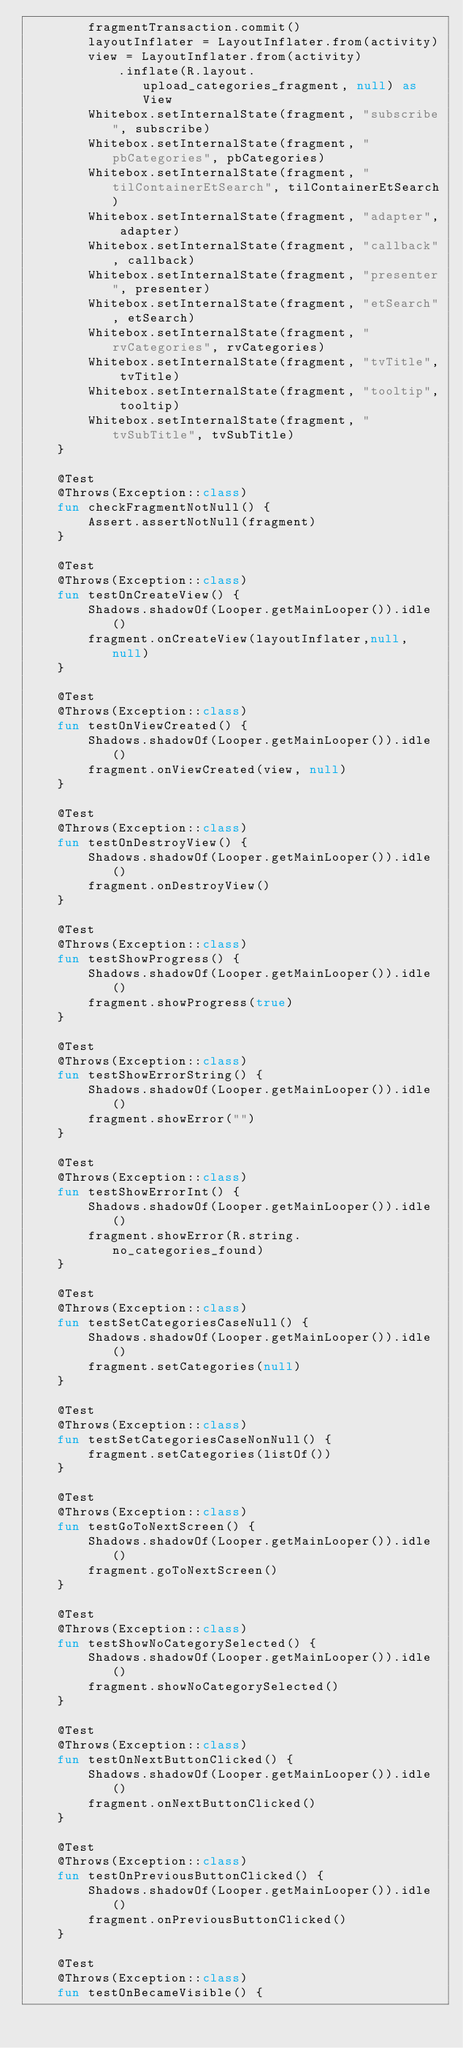Convert code to text. <code><loc_0><loc_0><loc_500><loc_500><_Kotlin_>        fragmentTransaction.commit()
        layoutInflater = LayoutInflater.from(activity)
        view = LayoutInflater.from(activity)
            .inflate(R.layout.upload_categories_fragment, null) as View
        Whitebox.setInternalState(fragment, "subscribe", subscribe)
        Whitebox.setInternalState(fragment, "pbCategories", pbCategories)
        Whitebox.setInternalState(fragment, "tilContainerEtSearch", tilContainerEtSearch)
        Whitebox.setInternalState(fragment, "adapter", adapter)
        Whitebox.setInternalState(fragment, "callback", callback)
        Whitebox.setInternalState(fragment, "presenter", presenter)
        Whitebox.setInternalState(fragment, "etSearch", etSearch)
        Whitebox.setInternalState(fragment, "rvCategories", rvCategories)
        Whitebox.setInternalState(fragment, "tvTitle", tvTitle)
        Whitebox.setInternalState(fragment, "tooltip", tooltip)
        Whitebox.setInternalState(fragment, "tvSubTitle", tvSubTitle)
    }

    @Test
    @Throws(Exception::class)
    fun checkFragmentNotNull() {
        Assert.assertNotNull(fragment)
    }

    @Test
    @Throws(Exception::class)
    fun testOnCreateView() {
        Shadows.shadowOf(Looper.getMainLooper()).idle()
        fragment.onCreateView(layoutInflater,null, null)
    }

    @Test
    @Throws(Exception::class)
    fun testOnViewCreated() {
        Shadows.shadowOf(Looper.getMainLooper()).idle()
        fragment.onViewCreated(view, null)
    }

    @Test
    @Throws(Exception::class)
    fun testOnDestroyView() {
        Shadows.shadowOf(Looper.getMainLooper()).idle()
        fragment.onDestroyView()
    }

    @Test
    @Throws(Exception::class)
    fun testShowProgress() {
        Shadows.shadowOf(Looper.getMainLooper()).idle()
        fragment.showProgress(true)
    }

    @Test
    @Throws(Exception::class)
    fun testShowErrorString() {
        Shadows.shadowOf(Looper.getMainLooper()).idle()
        fragment.showError("")
    }

    @Test
    @Throws(Exception::class)
    fun testShowErrorInt() {
        Shadows.shadowOf(Looper.getMainLooper()).idle()
        fragment.showError(R.string.no_categories_found)
    }

    @Test
    @Throws(Exception::class)
    fun testSetCategoriesCaseNull() {
        Shadows.shadowOf(Looper.getMainLooper()).idle()
        fragment.setCategories(null)
    }

    @Test
    @Throws(Exception::class)
    fun testSetCategoriesCaseNonNull() {
        fragment.setCategories(listOf())
    }

    @Test
    @Throws(Exception::class)
    fun testGoToNextScreen() {
        Shadows.shadowOf(Looper.getMainLooper()).idle()
        fragment.goToNextScreen()
    }

    @Test
    @Throws(Exception::class)
    fun testShowNoCategorySelected() {
        Shadows.shadowOf(Looper.getMainLooper()).idle()
        fragment.showNoCategorySelected()
    }

    @Test
    @Throws(Exception::class)
    fun testOnNextButtonClicked() {
        Shadows.shadowOf(Looper.getMainLooper()).idle()
        fragment.onNextButtonClicked()
    }

    @Test
    @Throws(Exception::class)
    fun testOnPreviousButtonClicked() {
        Shadows.shadowOf(Looper.getMainLooper()).idle()
        fragment.onPreviousButtonClicked()
    }

    @Test
    @Throws(Exception::class)
    fun testOnBecameVisible() {</code> 